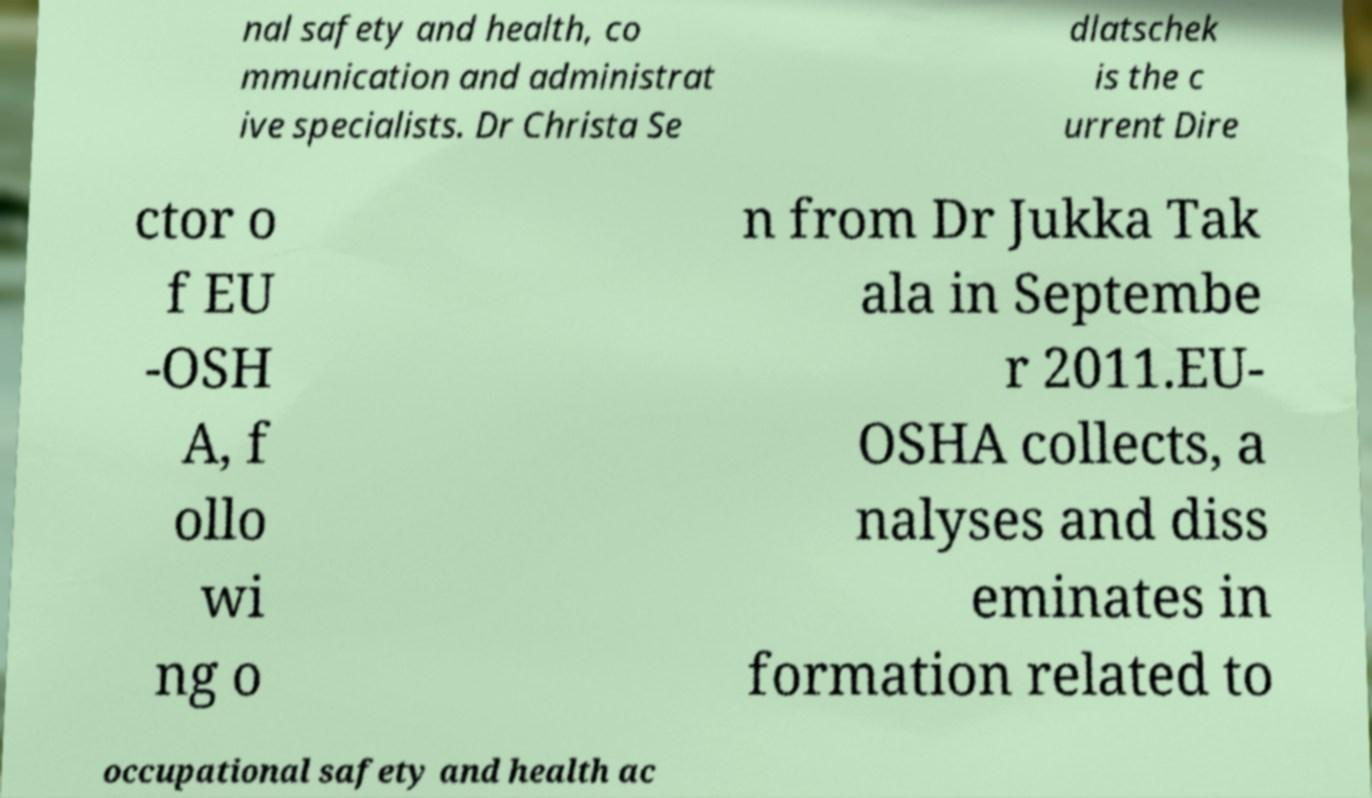Can you accurately transcribe the text from the provided image for me? nal safety and health, co mmunication and administrat ive specialists. Dr Christa Se dlatschek is the c urrent Dire ctor o f EU -OSH A, f ollo wi ng o n from Dr Jukka Tak ala in Septembe r 2011.EU- OSHA collects, a nalyses and diss eminates in formation related to occupational safety and health ac 